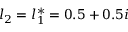Convert formula to latex. <formula><loc_0><loc_0><loc_500><loc_500>l _ { 2 } = l _ { 1 } ^ { * } = 0 . 5 + 0 . 5 i</formula> 